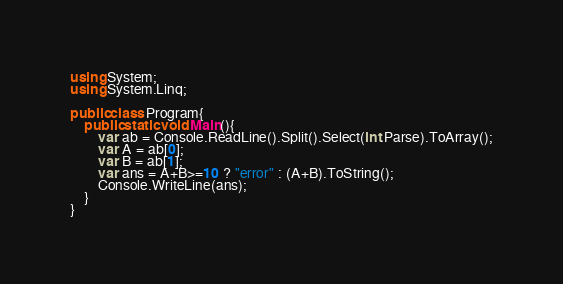Convert code to text. <code><loc_0><loc_0><loc_500><loc_500><_C#_>using System;
using System.Linq;

public class Program{
    public static void Main(){
        var ab = Console.ReadLine().Split().Select(int.Parse).ToArray();
        var A = ab[0];
        var B = ab[1];
        var ans = A+B>=10 ? "error" : (A+B).ToString(); 
        Console.WriteLine(ans);
    }
}
</code> 